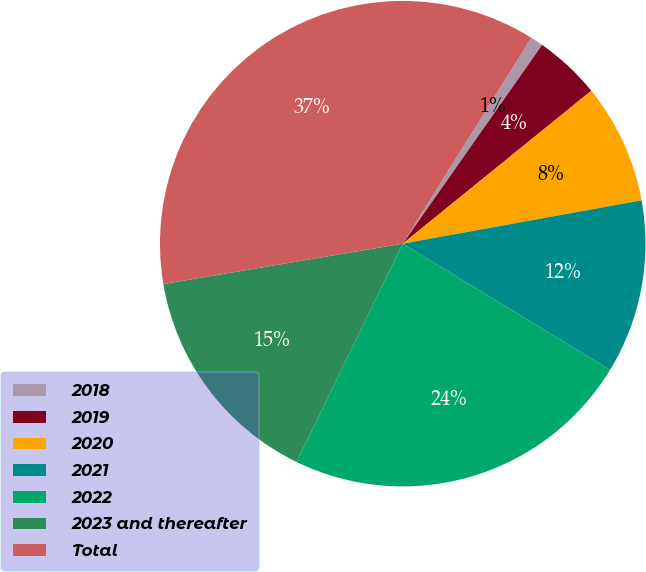<chart> <loc_0><loc_0><loc_500><loc_500><pie_chart><fcel>2018<fcel>2019<fcel>2020<fcel>2021<fcel>2022<fcel>2023 and thereafter<fcel>Total<nl><fcel>0.85%<fcel>4.42%<fcel>7.99%<fcel>11.56%<fcel>23.51%<fcel>15.13%<fcel>36.55%<nl></chart> 